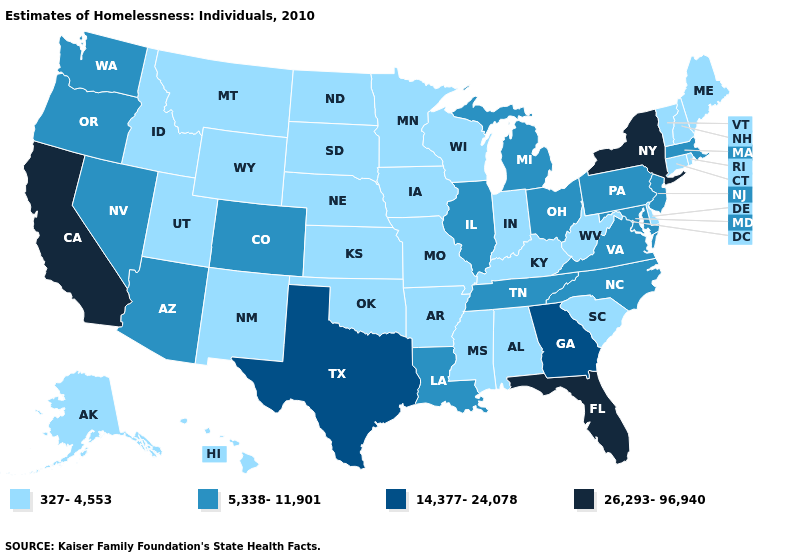Name the states that have a value in the range 14,377-24,078?
Keep it brief. Georgia, Texas. How many symbols are there in the legend?
Concise answer only. 4. Name the states that have a value in the range 5,338-11,901?
Keep it brief. Arizona, Colorado, Illinois, Louisiana, Maryland, Massachusetts, Michigan, Nevada, New Jersey, North Carolina, Ohio, Oregon, Pennsylvania, Tennessee, Virginia, Washington. What is the highest value in states that border Pennsylvania?
Keep it brief. 26,293-96,940. What is the highest value in the MidWest ?
Write a very short answer. 5,338-11,901. What is the value of South Carolina?
Short answer required. 327-4,553. What is the value of Hawaii?
Be succinct. 327-4,553. What is the lowest value in states that border New York?
Quick response, please. 327-4,553. What is the value of West Virginia?
Quick response, please. 327-4,553. Does New York have the highest value in the Northeast?
Keep it brief. Yes. Among the states that border Nebraska , does Colorado have the lowest value?
Give a very brief answer. No. What is the value of Colorado?
Answer briefly. 5,338-11,901. What is the highest value in states that border Massachusetts?
Give a very brief answer. 26,293-96,940. Does Missouri have the lowest value in the MidWest?
Be succinct. Yes. Among the states that border Massachusetts , does New York have the highest value?
Short answer required. Yes. 